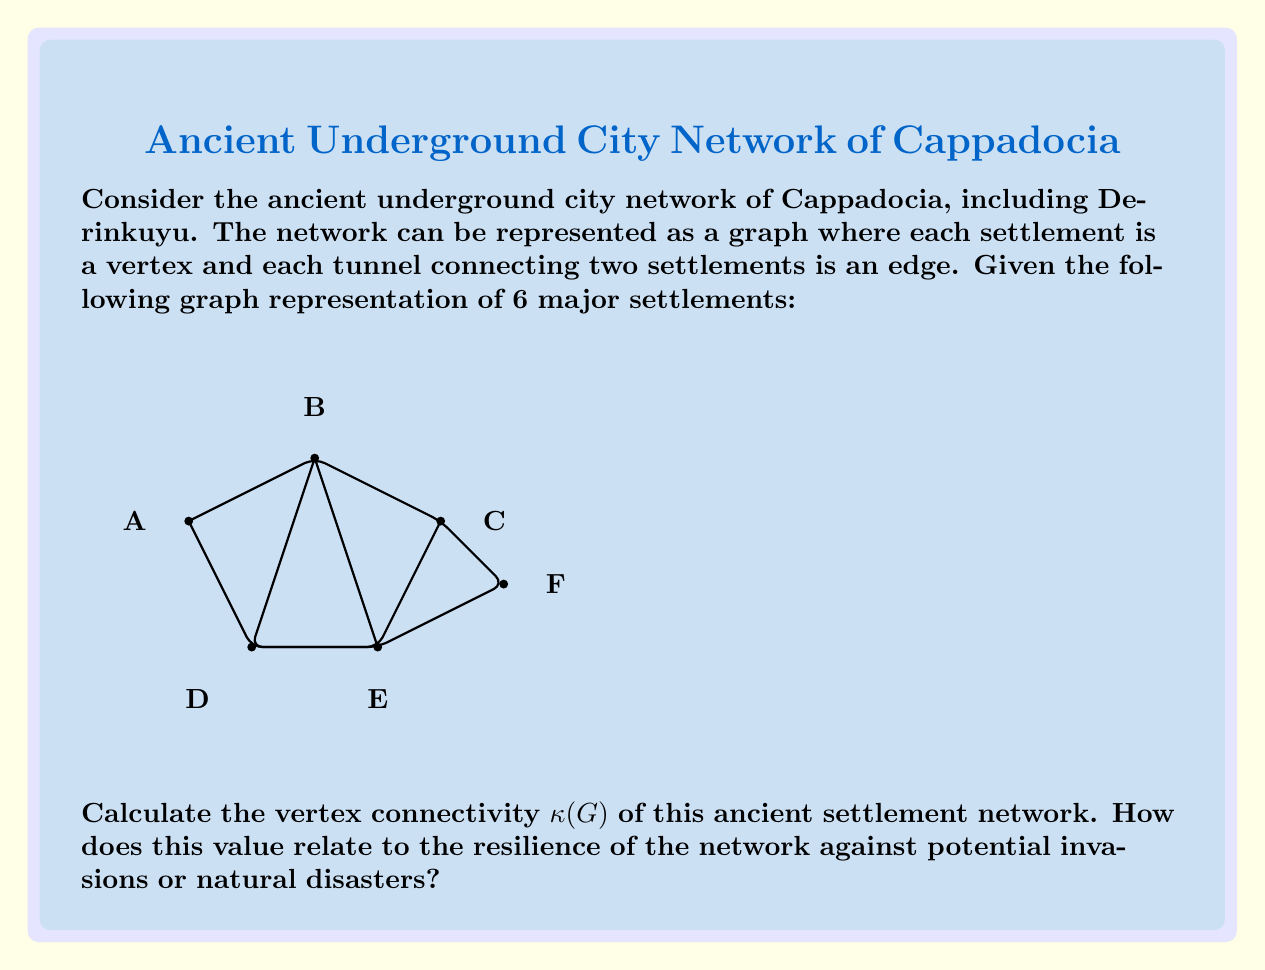Help me with this question. To solve this problem, we need to follow these steps:

1) Recall that the vertex connectivity $\kappa(G)$ of a graph G is the minimum number of vertices whose removal results in a disconnected graph or a graph with only one vertex.

2) For this graph, we need to consider different combinations of vertex removals:

   - Removing any single vertex does not disconnect the graph.
   - Removing vertices A and F disconnects the graph into two components: {B,C,E} and {D}.
   - There is no single vertex whose removal disconnects the graph.

3) Therefore, the vertex connectivity $\kappa(G) = 2$.

4) Interpretation in the context of ancient settlements:
   - The vertex connectivity of 2 indicates that the network is relatively robust.
   - At least two settlements need to be compromised to completely disrupt communication in the network.
   - This suggests that the ancient builders designed the network with some level of redundancy and resilience against potential threats.

5) Relation to network resilience:
   - Higher vertex connectivity generally indicates greater network resilience.
   - In this case, $\kappa(G) = 2$ suggests moderate resilience.
   - The network could withstand the loss of any single settlement without becoming disconnected.
   - However, strategic attacks or disasters affecting two key settlements could significantly disrupt the network.

This analysis provides insights into the structural integrity and strategic design of the ancient underground city network in Cappadocia.
Answer: $\kappa(G) = 2$ 